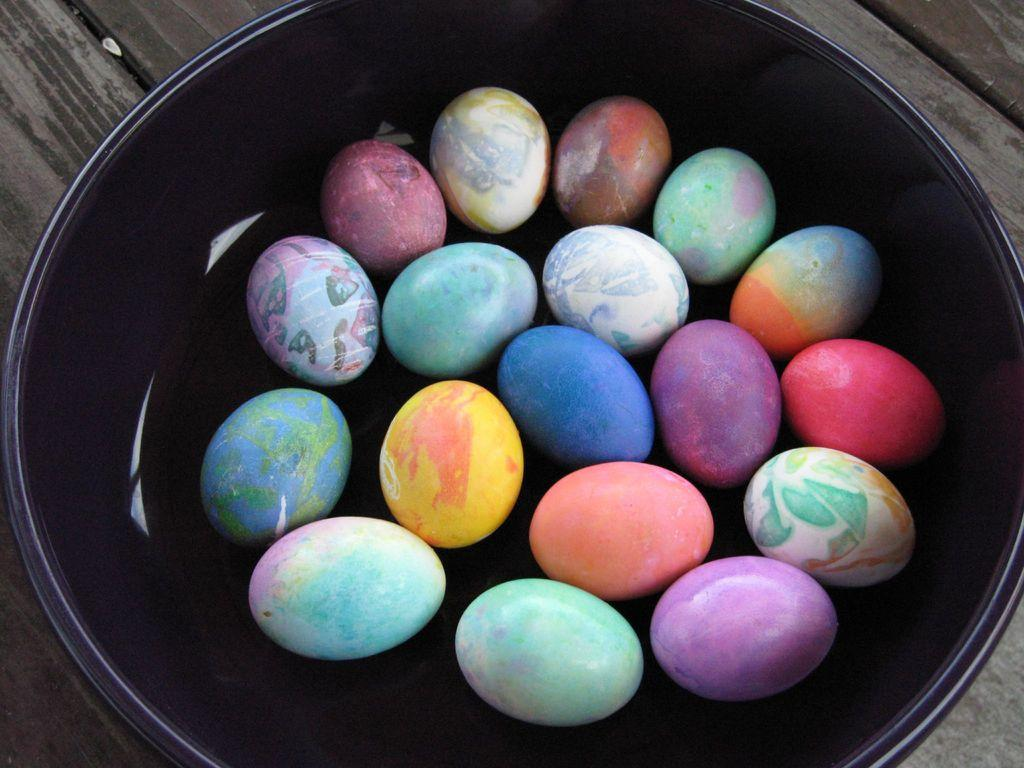What type of objects are present in the image? There are colorful eggs in the image. What is the bowl made of? The bowl is black in color. What is the material of the surface on which the bowl is placed? The bowl is kept on a wooden surface. How many times do the eggs fall and land on the wooden surface in the image? The eggs do not fall or land on the wooden surface in the image; they are already in the bowl. 